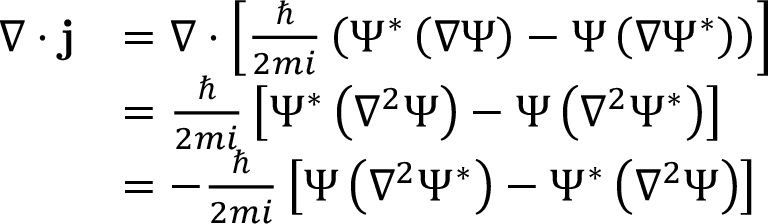<formula> <loc_0><loc_0><loc_500><loc_500>{ \begin{array} { r l } { \nabla \cdot j } & { = \nabla \cdot \left [ { \frac { } { 2 m i } } \left ( \Psi ^ { * } \left ( \nabla \Psi \right ) - \Psi \left ( \nabla \Psi ^ { * } \right ) \right ) \right ] } \\ & { = { \frac { } { 2 m i } } \left [ \Psi ^ { * } \left ( \nabla ^ { 2 } \Psi \right ) - \Psi \left ( \nabla ^ { 2 } \Psi ^ { * } \right ) \right ] } \\ & { = - { \frac { } { 2 m i } } \left [ \Psi \left ( \nabla ^ { 2 } \Psi ^ { * } \right ) - \Psi ^ { * } \left ( \nabla ^ { 2 } \Psi \right ) \right ] } \end{array} }</formula> 